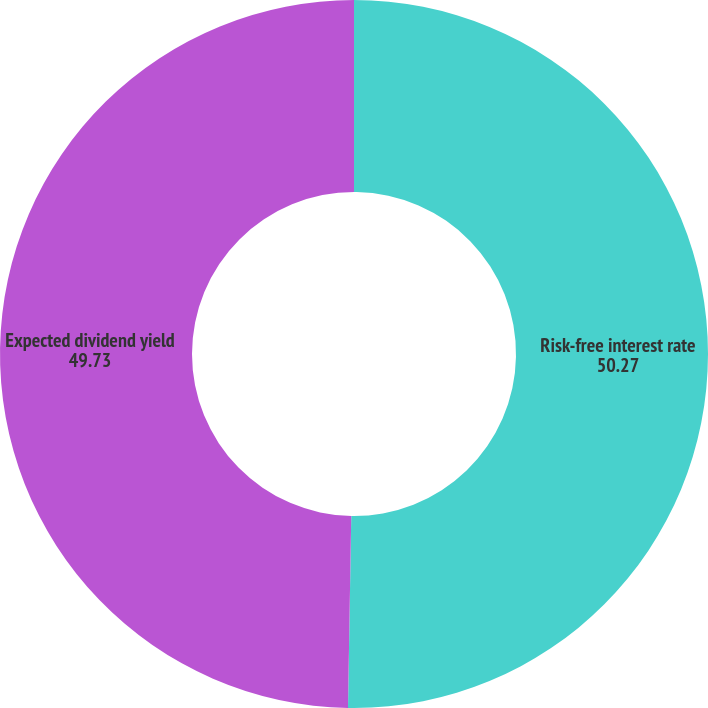Convert chart to OTSL. <chart><loc_0><loc_0><loc_500><loc_500><pie_chart><fcel>Risk-free interest rate<fcel>Expected dividend yield<nl><fcel>50.27%<fcel>49.73%<nl></chart> 